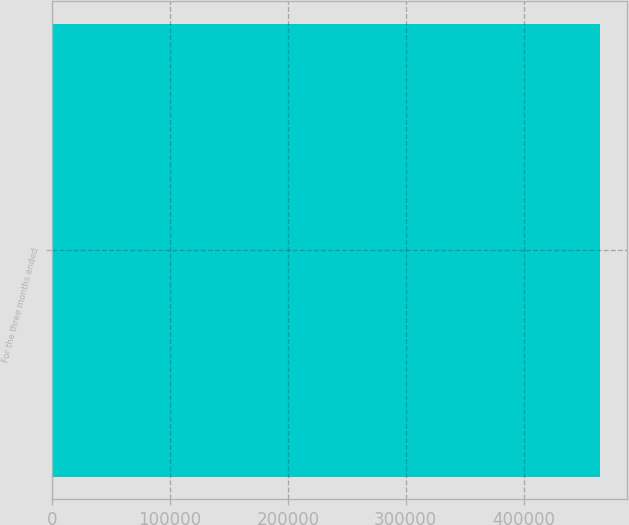<chart> <loc_0><loc_0><loc_500><loc_500><bar_chart><fcel>For the three months ended<nl><fcel>464924<nl></chart> 